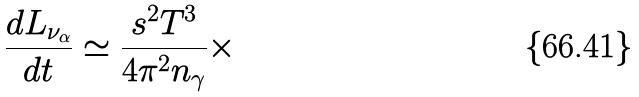<formula> <loc_0><loc_0><loc_500><loc_500>\frac { d L _ { \nu _ { \alpha } } } { d t } \simeq \frac { s ^ { 2 } T ^ { 3 } } { 4 \pi ^ { 2 } n _ { \gamma } } \times</formula> 